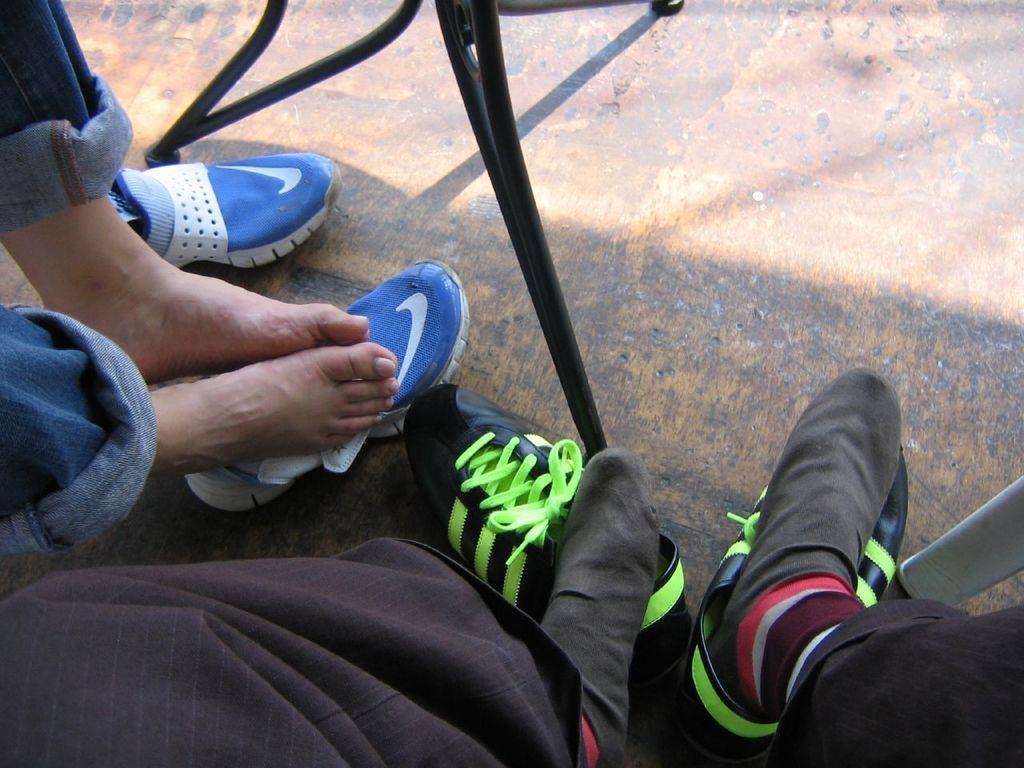Please provide a concise description of this image. In this image I can see legs of people and I can see few shoes. I can also see color of these shoes are blue and black. 